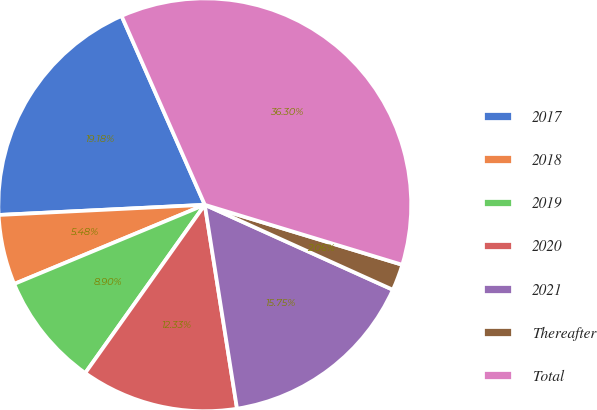Convert chart. <chart><loc_0><loc_0><loc_500><loc_500><pie_chart><fcel>2017<fcel>2018<fcel>2019<fcel>2020<fcel>2021<fcel>Thereafter<fcel>Total<nl><fcel>19.18%<fcel>5.48%<fcel>8.9%<fcel>12.33%<fcel>15.75%<fcel>2.06%<fcel>36.3%<nl></chart> 